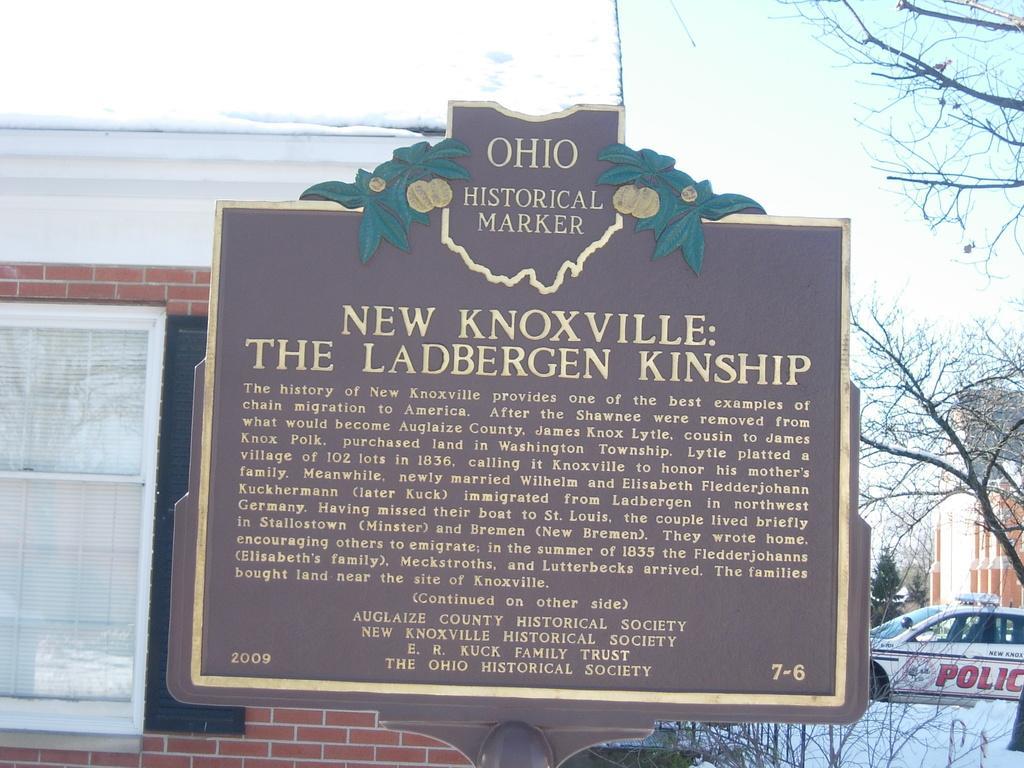Could you give a brief overview of what you see in this image? In the foreground of this image, there is a name board. In the background, we can see a building, a window, a tree, a police car and the sky. 